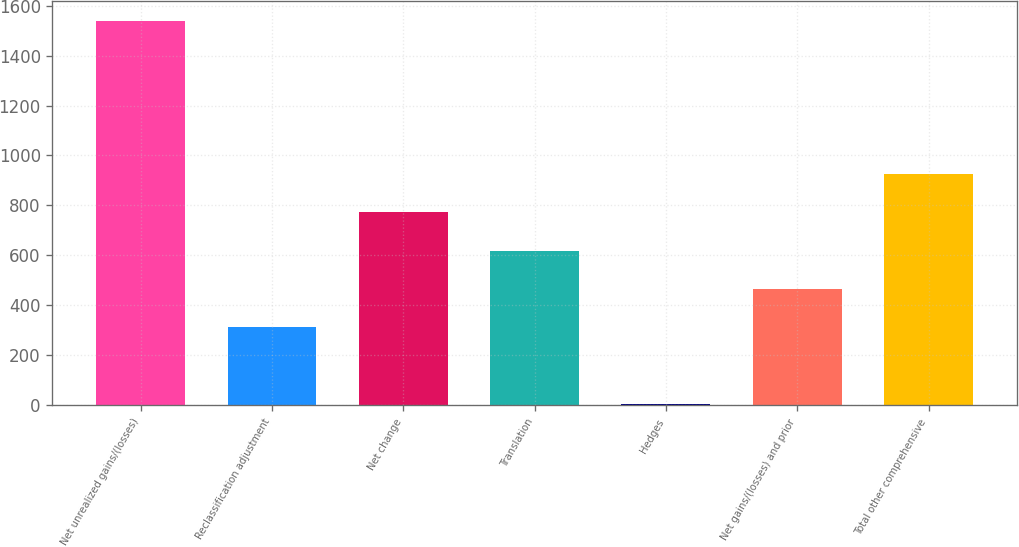Convert chart. <chart><loc_0><loc_0><loc_500><loc_500><bar_chart><fcel>Net unrealized gains/(losses)<fcel>Reclassification adjustment<fcel>Net change<fcel>Translation<fcel>Hedges<fcel>Net gains/(losses) and prior<fcel>Total other comprehensive<nl><fcel>1540<fcel>312<fcel>772.5<fcel>619<fcel>5<fcel>465.5<fcel>926<nl></chart> 